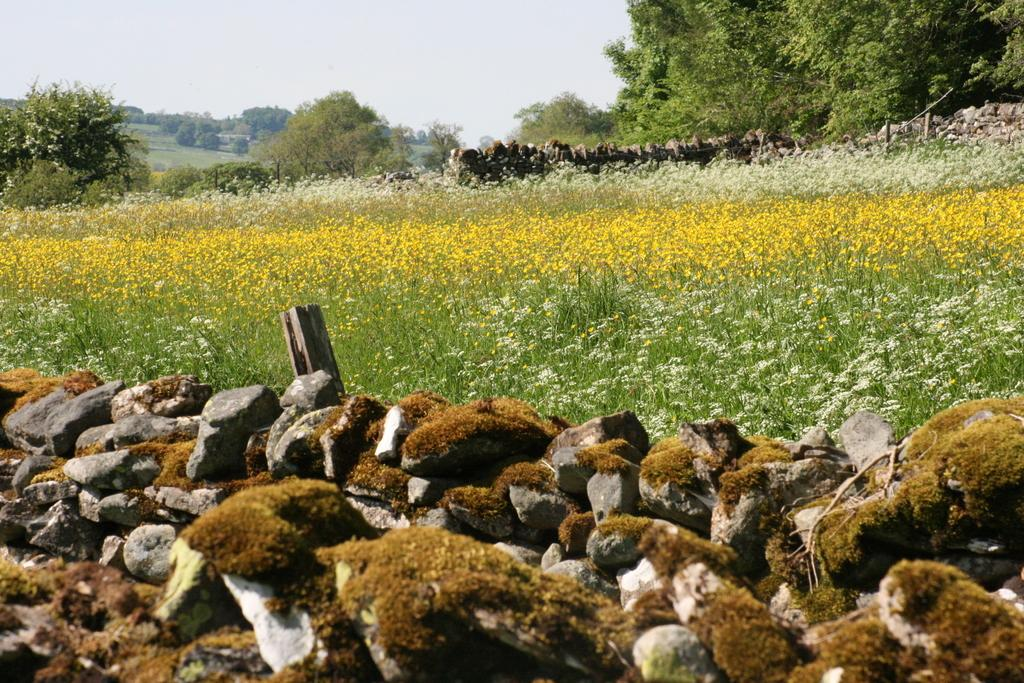What is located at the bottom of the image? There are stones and a wooden pole at the bottom of the image. What can be seen in the background of the image? There are flower plants, stones, trees, and the sky visible in the background of the image. What color paint is being used on the cap of the rifle in the image? There is no paint, cap, or rifle present in the image. How many rifles can be seen in the image? There are no rifles present in the image. 